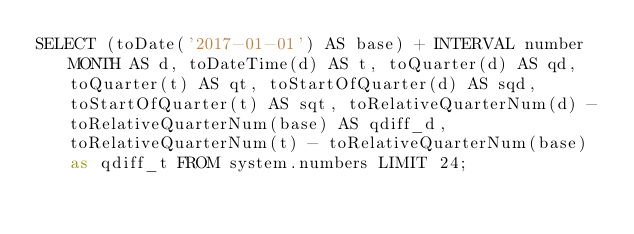<code> <loc_0><loc_0><loc_500><loc_500><_SQL_>SELECT (toDate('2017-01-01') AS base) + INTERVAL number MONTH AS d, toDateTime(d) AS t, toQuarter(d) AS qd, toQuarter(t) AS qt, toStartOfQuarter(d) AS sqd, toStartOfQuarter(t) AS sqt, toRelativeQuarterNum(d) - toRelativeQuarterNum(base) AS qdiff_d, toRelativeQuarterNum(t) - toRelativeQuarterNum(base) as qdiff_t FROM system.numbers LIMIT 24;
</code> 